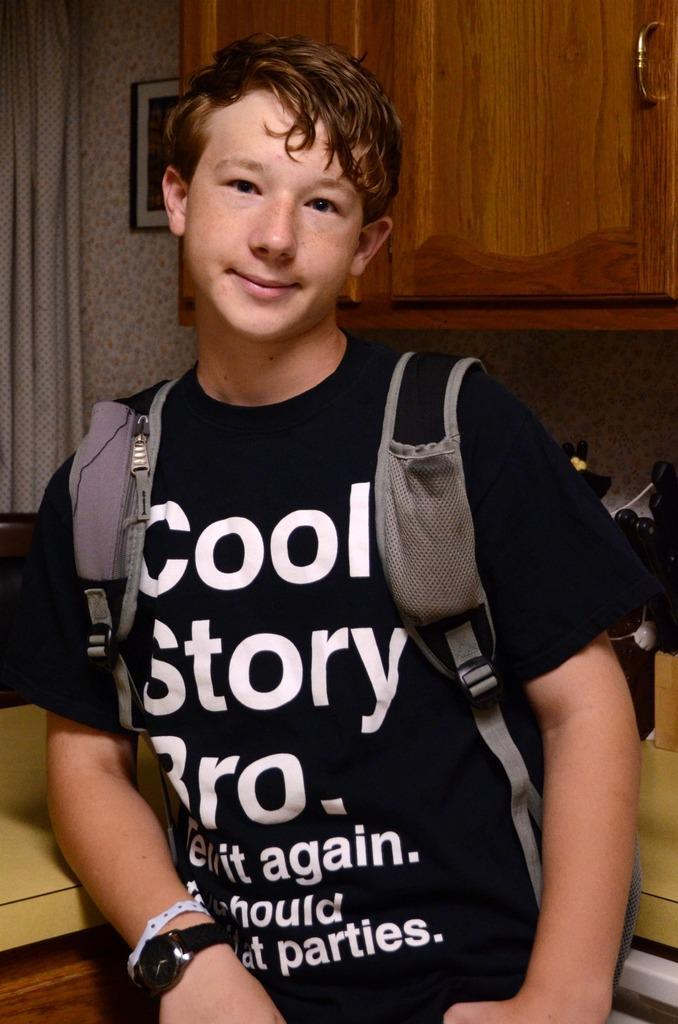Please provide a concise description of this image. In the center of the image we can see a person standing. He is wearing a bag. In the background there is a cupboard, curtain and a counter table and we can see a frame placed on the wall. 